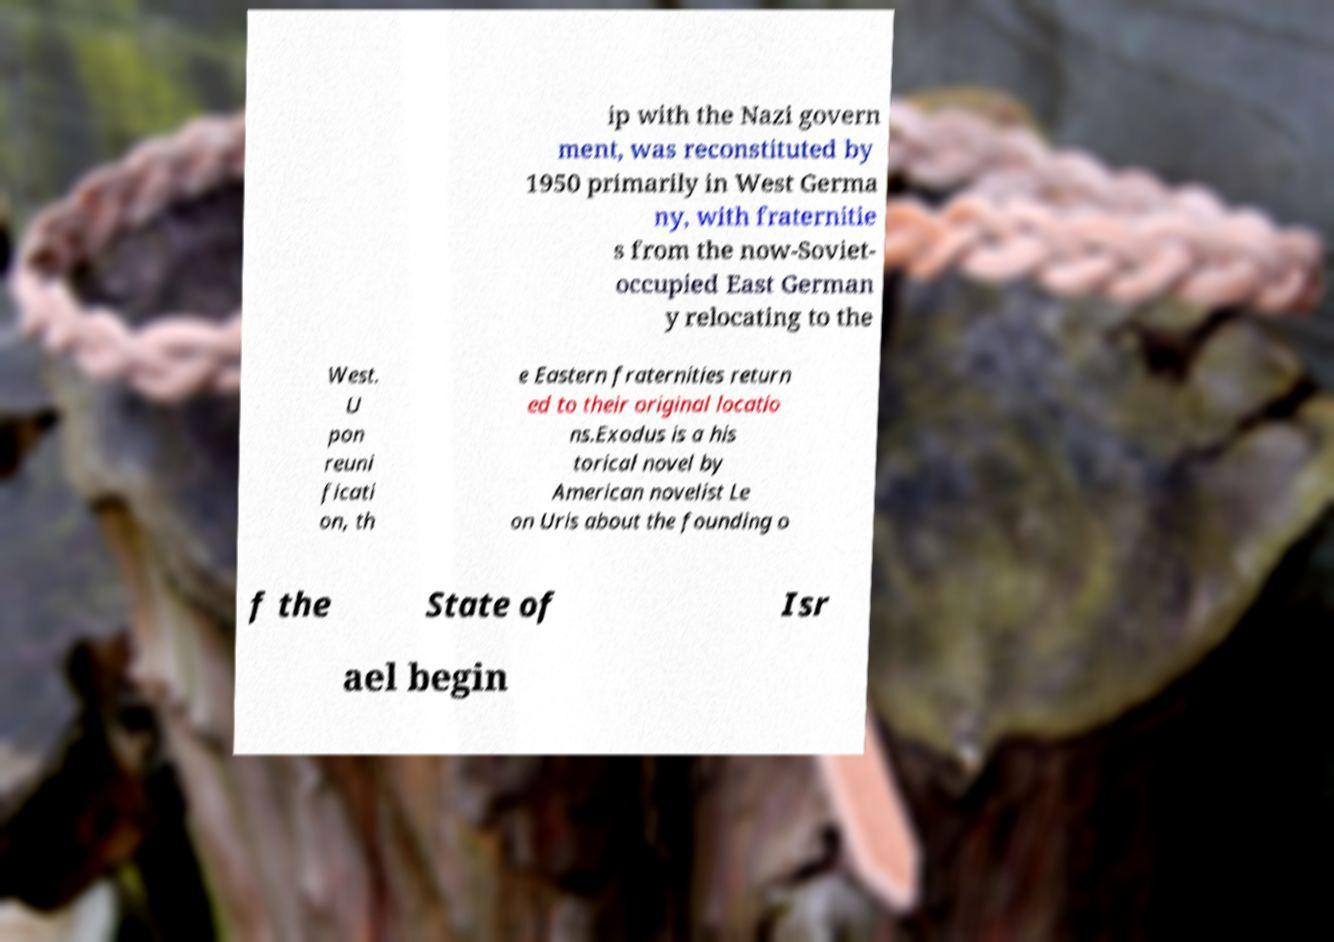There's text embedded in this image that I need extracted. Can you transcribe it verbatim? ip with the Nazi govern ment, was reconstituted by 1950 primarily in West Germa ny, with fraternitie s from the now-Soviet- occupied East German y relocating to the West. U pon reuni ficati on, th e Eastern fraternities return ed to their original locatio ns.Exodus is a his torical novel by American novelist Le on Uris about the founding o f the State of Isr ael begin 